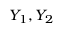Convert formula to latex. <formula><loc_0><loc_0><loc_500><loc_500>Y _ { 1 } , Y _ { 2 }</formula> 